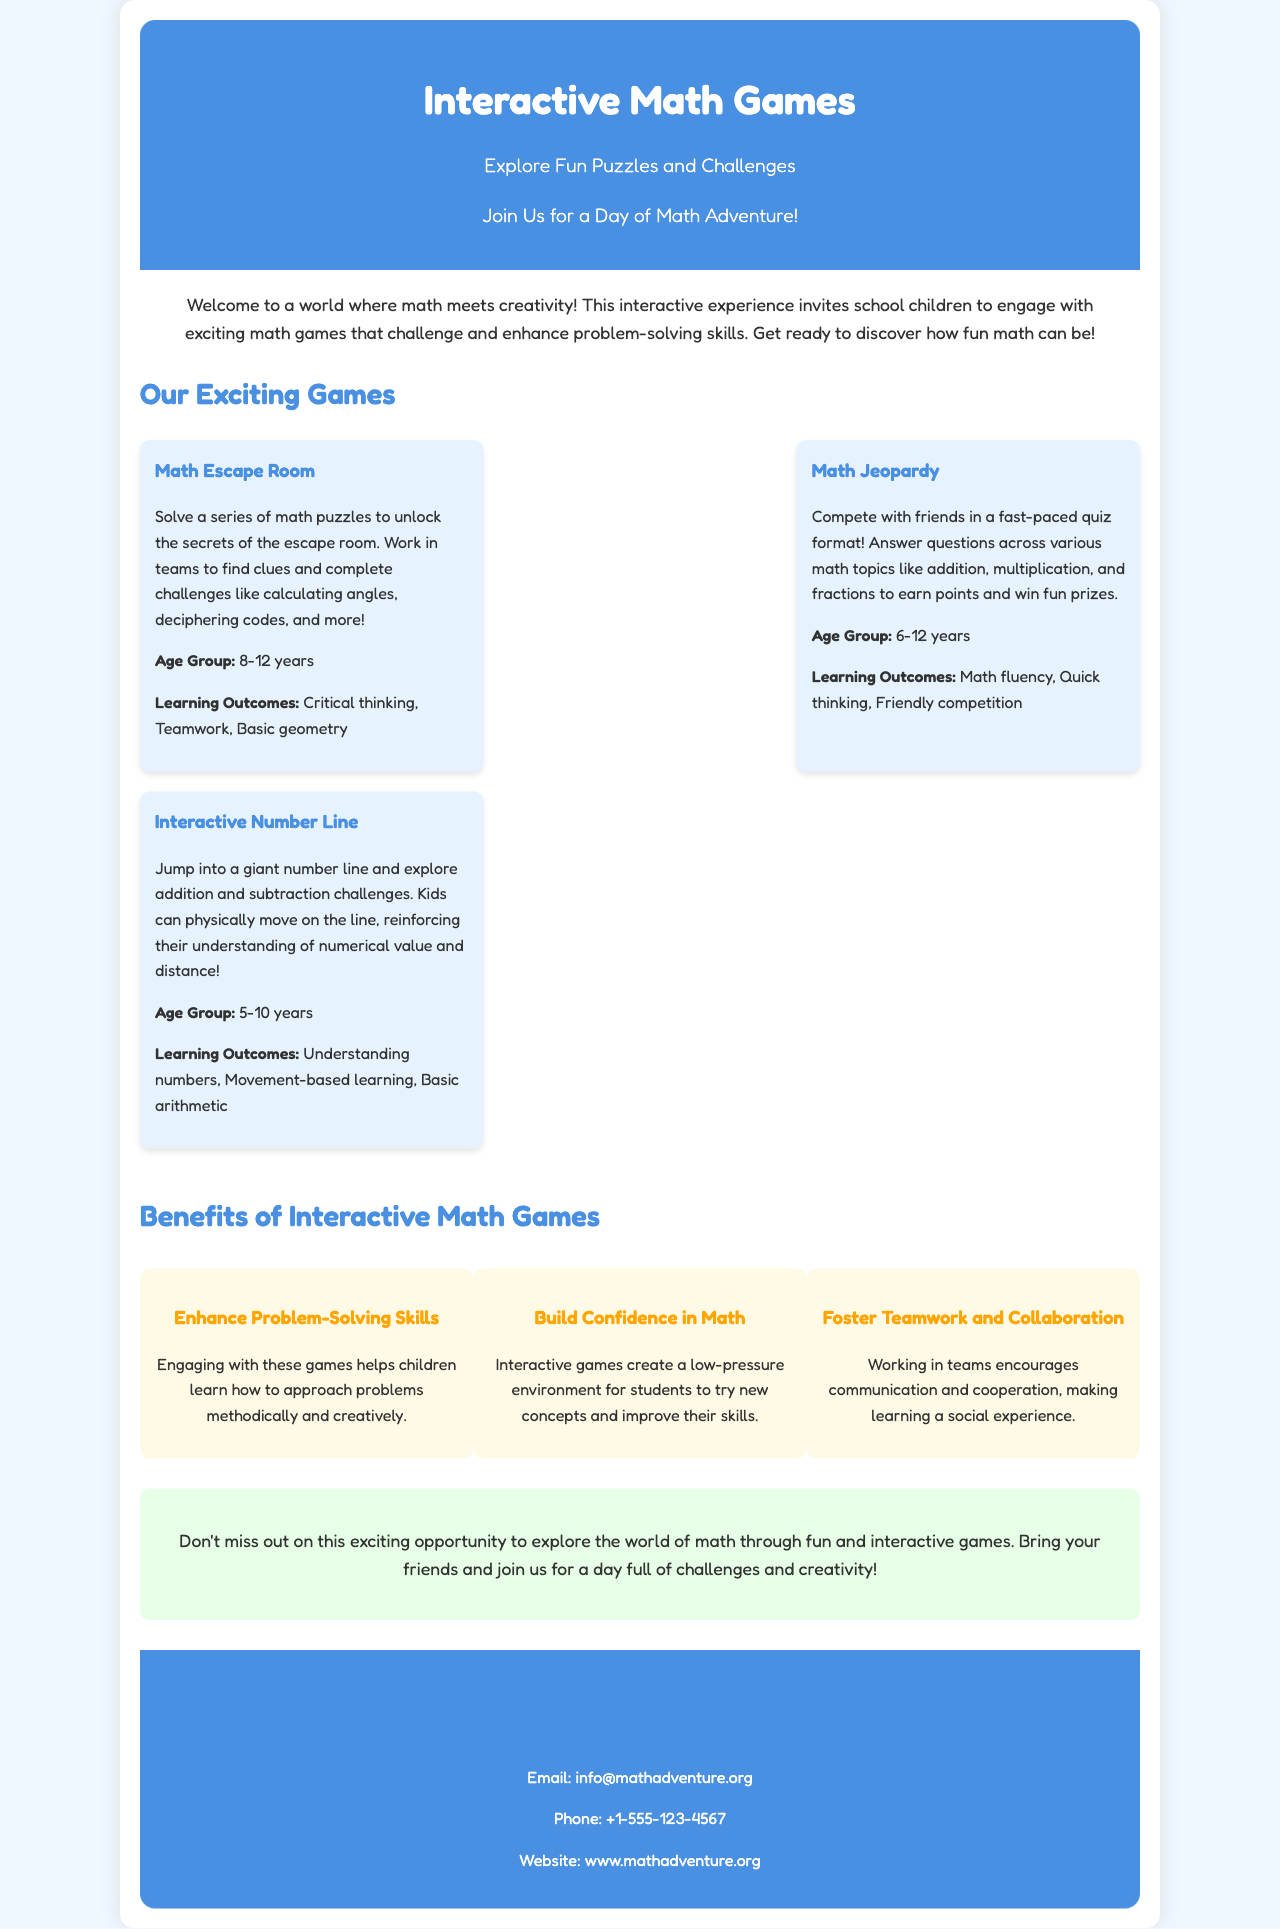what is the age group for Math Escape Room? The age group for Math Escape Room is specified in the document under the game's description.
Answer: 8-12 years what are the learning outcomes of Math Jeopardy? The learning outcomes can be found in the description of Math Jeopardy within the brochure.
Answer: Math fluency, Quick thinking, Friendly competition how many games are listed in the brochure? The number of games is determined by counting the game sections provided in the document.
Answer: 3 what is one benefit of interactive math games mentioned in the brochure? Benefits are outlined in a section dedicated to them, listing multiple aspects.
Answer: Enhance Problem-Solving Skills what is the website for Math Adventure? The website is provided in the contact information section towards the end of the document.
Answer: www.mathadventure.org what type of document is this? The overall structure and content indicate that this is a promotional material designed to inform and engage participants.
Answer: Brochure 